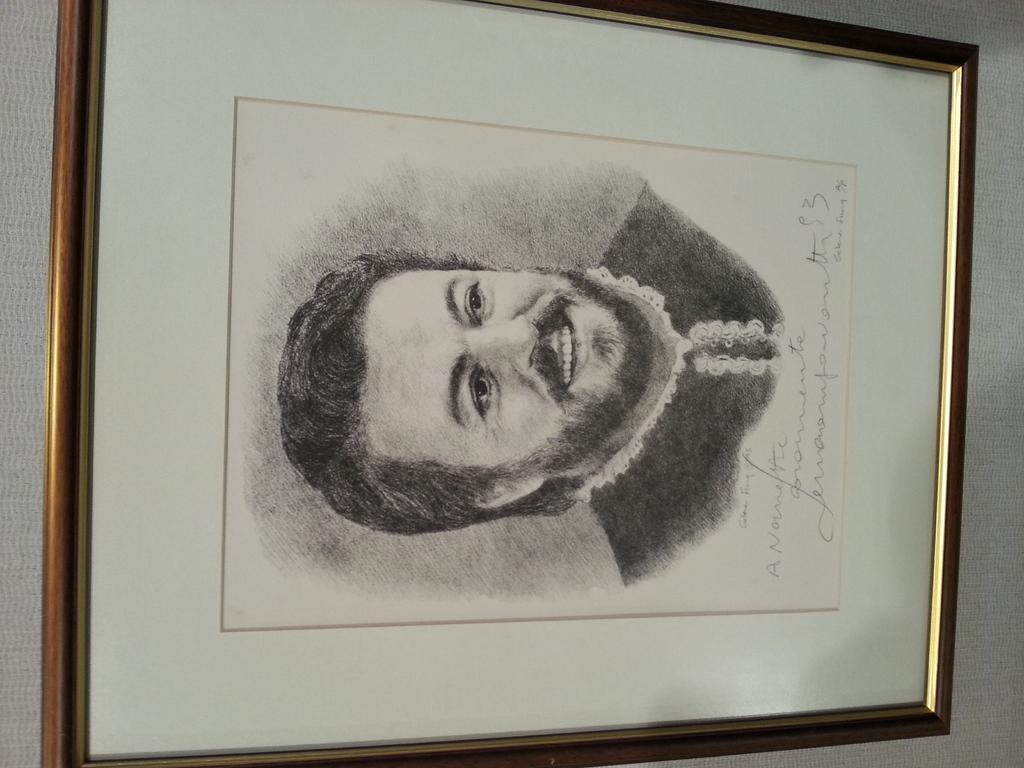What object in the image contains a visual representation? There is a photo frame in the image that contains a visual representation. What type of visual representation can be seen in the image? There is a sketch of a person in the image. What type of text is present in the image? There is handwritten text in the image. What emotion does the person in the sketch express when they receive a shock? There is no indication of emotion in the sketch, as it is a static image and does not depict a specific moment or reaction. 